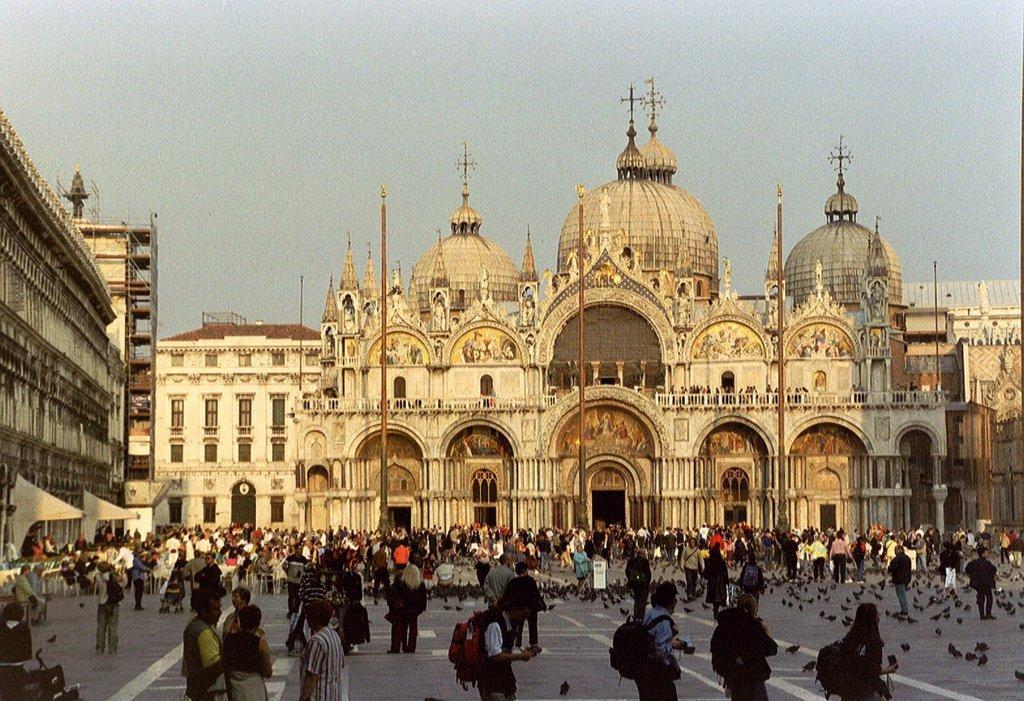In one or two sentences, can you explain what this image depicts? As we can see in the image there are buildings, windows, poles, few people walking here and there, birds and sky. 